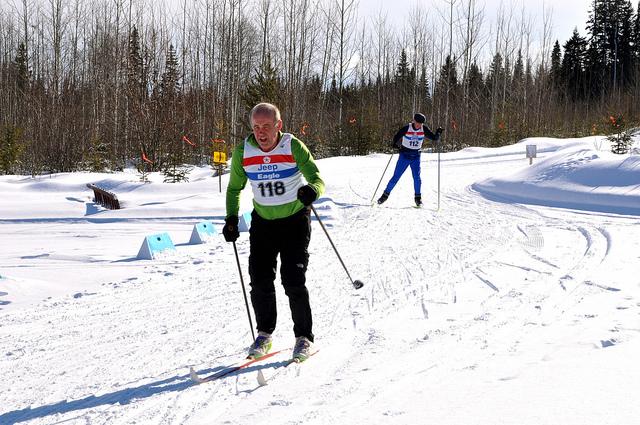What number is on both skier's jerseys?
Write a very short answer. 118. What sport is this?
Write a very short answer. Skiing. What numbers are on the man in green's shirt?
Concise answer only. 118. What is covering the ground?
Answer briefly. Snow. 